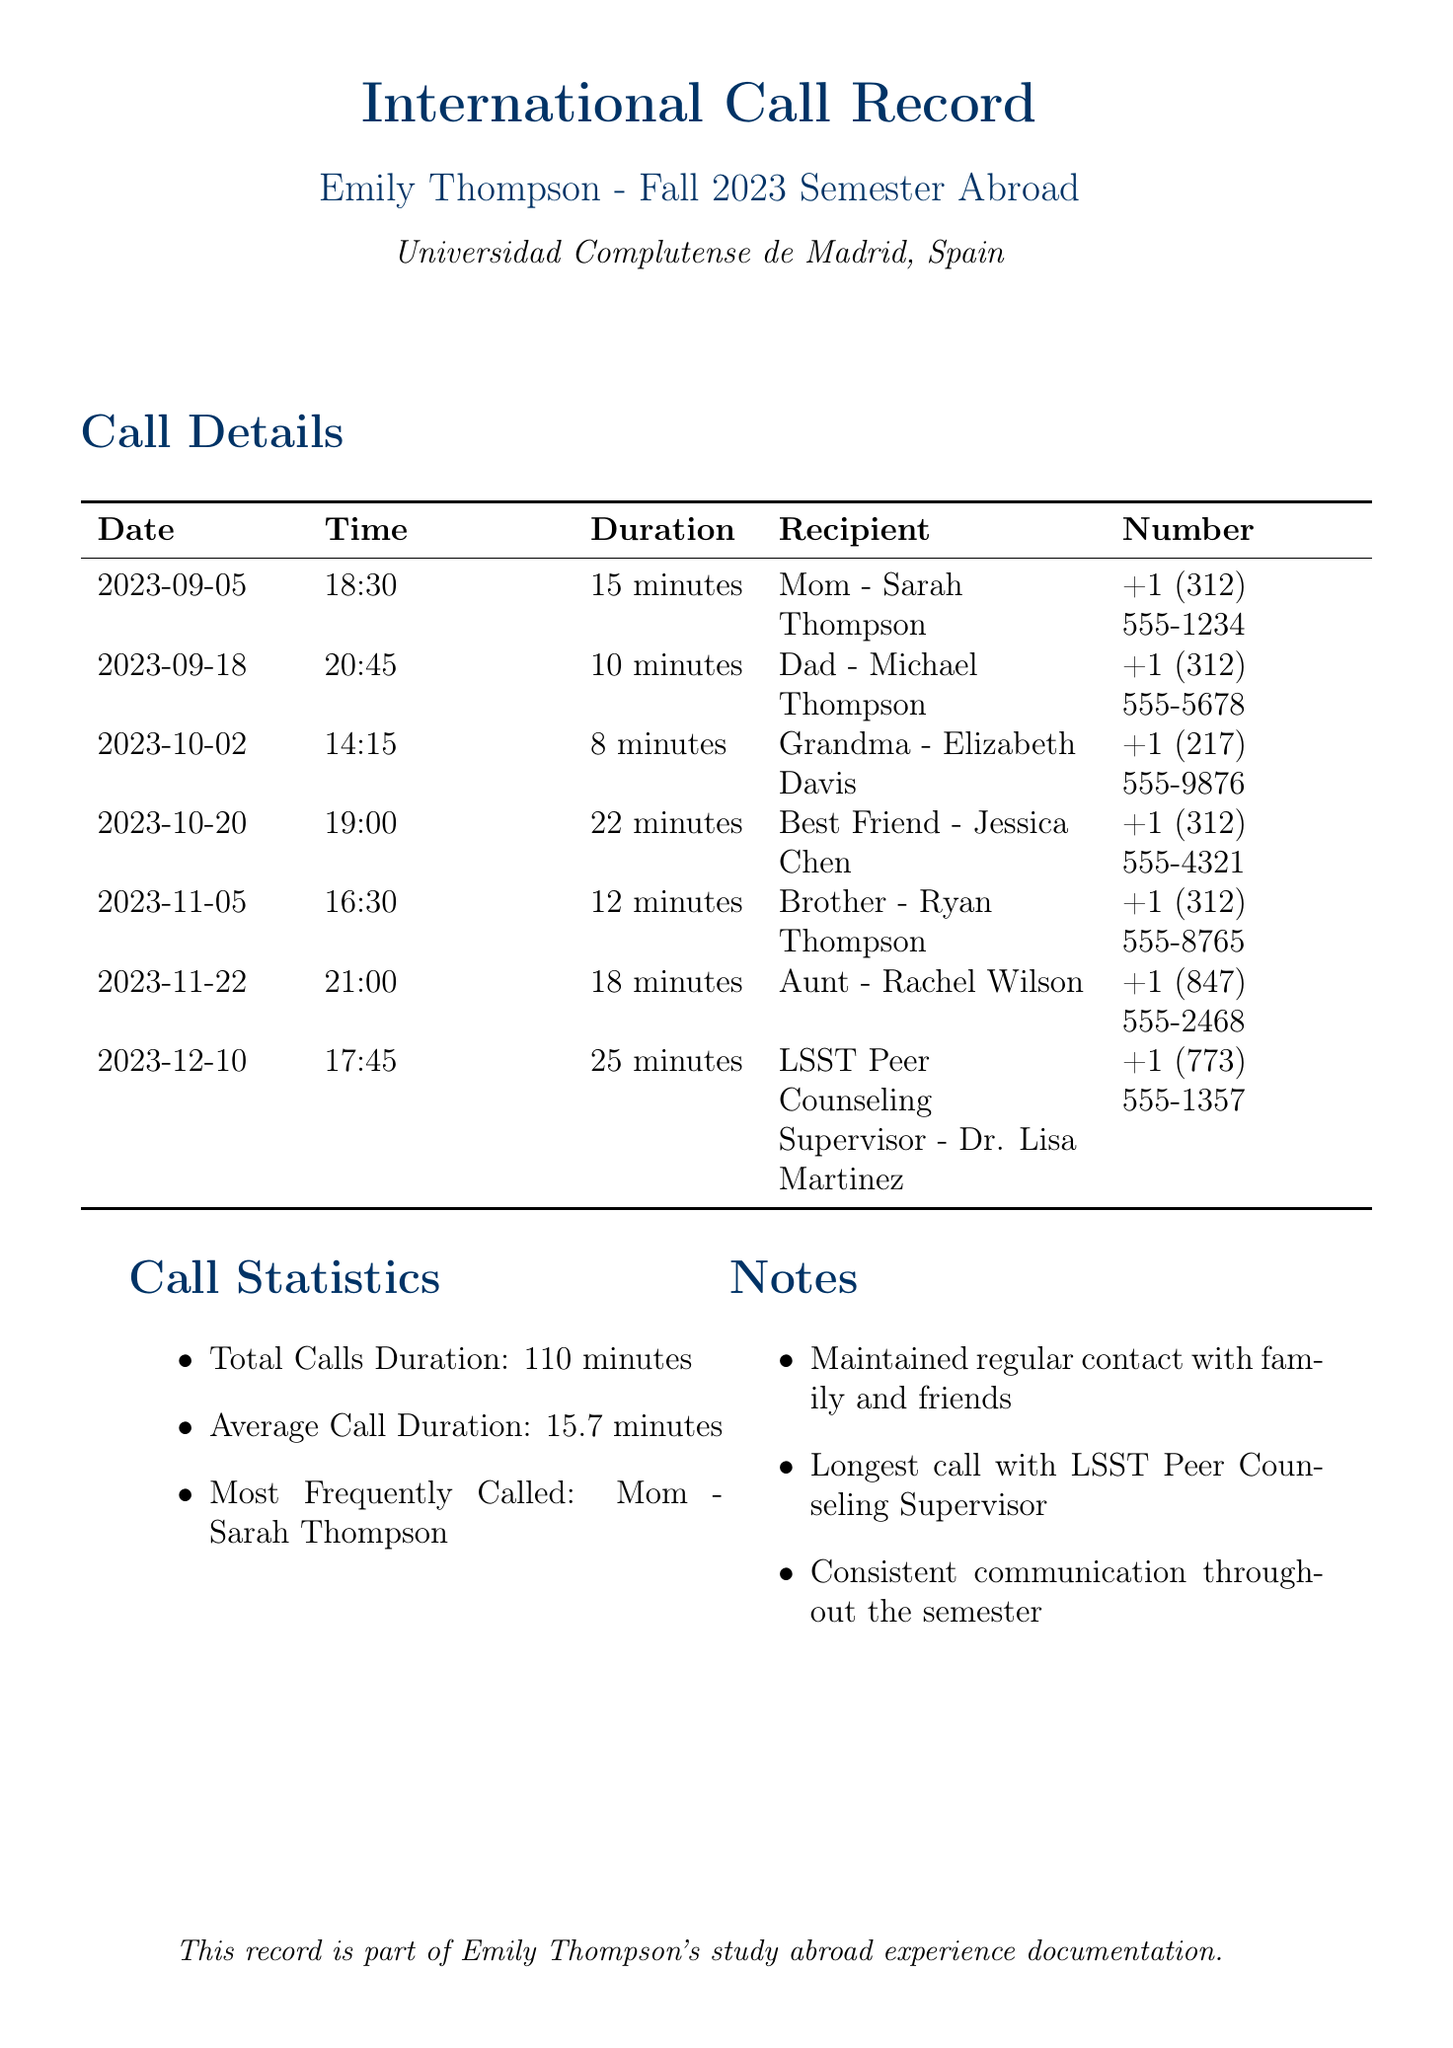What is the total calls duration? The total calls duration is mentioned in the call statistics section of the document.
Answer: 110 minutes Who is the most frequently called person? The most frequently called person is noted in the call statistics section.
Answer: Mom - Sarah Thompson What is the date of the longest call? The date corresponding to the longest call can be identified from the call details.
Answer: 2023-12-10 How many calls were made to family members? The total number of calls can be counted from the call details listed in the document.
Answer: 6 calls What time was the call made to Grandma? The time for the call to Grandma is specified in the call details.
Answer: 14:15 What was the average call duration? The average call duration is presented in the call statistics section.
Answer: 15.7 minutes How many minutes was the call made to the Aunt? The duration of the call to the Aunt can be found in the call details.
Answer: 18 minutes Who was the recipient of the call on October 20th? The recipient's name can be found in the call details for that date.
Answer: Best Friend - Jessica Chen What is the duration of the call made to the supervisor? The duration of the call to the LSST Peer Counseling Supervisor is specified in the call details.
Answer: 25 minutes 